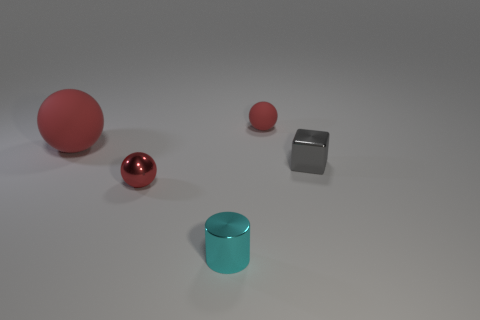Does the tiny rubber sphere have the same color as the rubber thing that is left of the tiny red shiny sphere?
Give a very brief answer. Yes. Do the rubber sphere in front of the tiny red rubber sphere and the shiny sphere have the same color?
Give a very brief answer. Yes. Are there any big spheres that have the same color as the tiny matte ball?
Offer a very short reply. Yes. Is the metal sphere the same color as the large ball?
Give a very brief answer. Yes. How many other things are the same color as the small shiny sphere?
Give a very brief answer. 2. What material is the other tiny object that is the same color as the tiny rubber thing?
Offer a terse response. Metal. What color is the cylinder?
Ensure brevity in your answer.  Cyan. Is there a cyan metal thing that is to the left of the tiny metal thing that is right of the tiny cyan cylinder?
Make the answer very short. Yes. Are there fewer small shiny cubes that are in front of the tiny shiny cylinder than big purple matte cylinders?
Your response must be concise. No. Is the tiny red sphere that is on the right side of the small cylinder made of the same material as the gray block?
Give a very brief answer. No. 